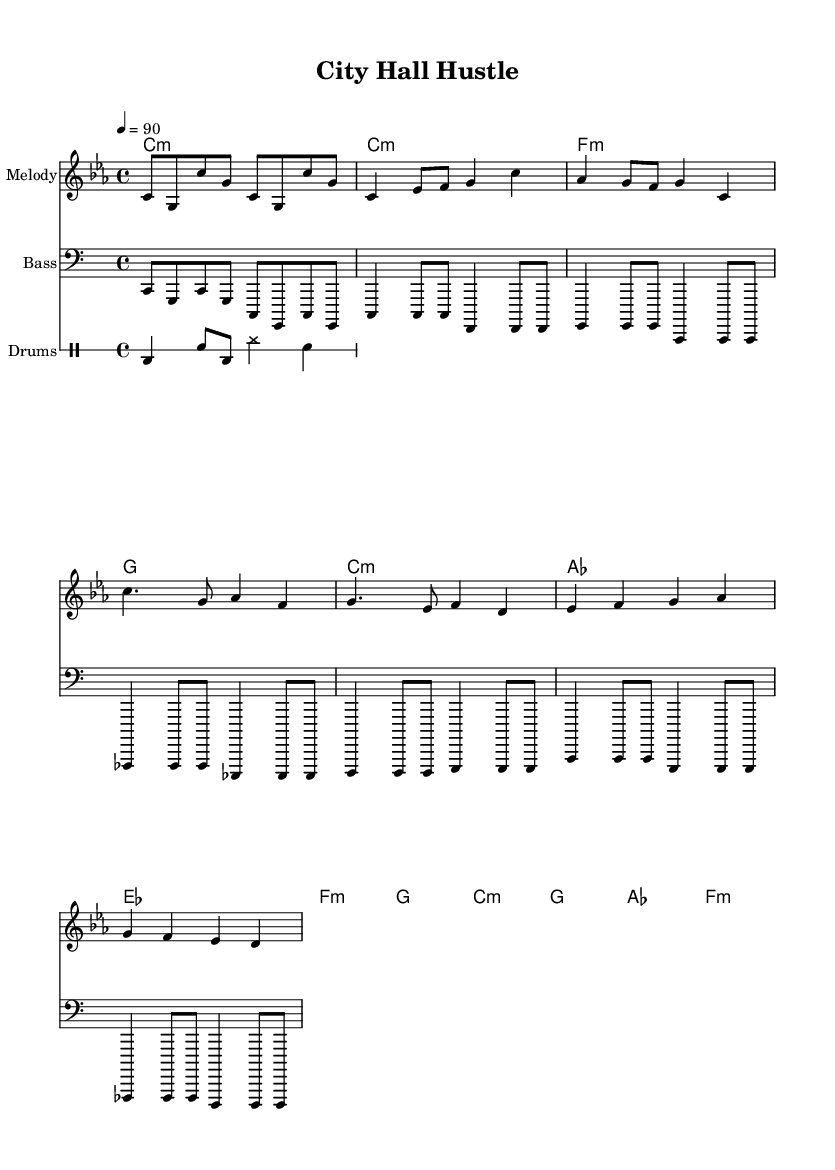What is the key signature of this music? The key signature of the music is C minor, which has three flats (B-flat, E-flat, and A-flat). This can be identified by looking for the flat symbols at the beginning of the staff.
Answer: C minor What is the time signature of this music? The time signature is 4/4, which indicates that there are four beats per measure and a quarter note receives one beat. This can be seen in the time signature marking located at the start of the piece.
Answer: 4/4 What is the tempo marking of this music? The tempo marking indicates a speed of 90 beats per minute, as shown by the notation "4 = 90" at the beginning of the score. This directs performers on how fast to play the piece.
Answer: 90 How many measures are there in the provided segment of music? By counting the distinct vertical lines separating the sections, which represent measures, we can determine that there are 14 measures in total.
Answer: 14 What musical form does this piece follow? The structure of the piece can be identified as following a pattern of "Intro - Verse - Chorus - Bridge," suggesting a typical song form commonly used in hip hop music. This can be inferred from the labeled sections in the music.
Answer: Intro - Verse - Chorus - Bridge Which instrument plays the bass line? The bass line is written in the bass clef, which typically represents lower-pitched instruments. In this piece, the bass is specifically noted, indicating it is the Bass instrument.
Answer: Bass What types of rhythms are present in the drum pattern? The drum pattern includes a combination of bass drum (bd), snare drum (sn), and hi-hat (hh) rhythms, which are characteristic of hip hop beats. The presence of these elements creates the foundational rhythm for the track.
Answer: Bass, Snare, Hi-hat 